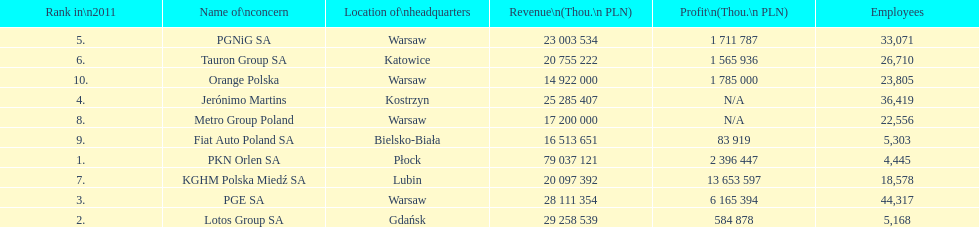What corporation is the only one with an income higher than 75,000,000 thou. pln? PKN Orlen SA. 